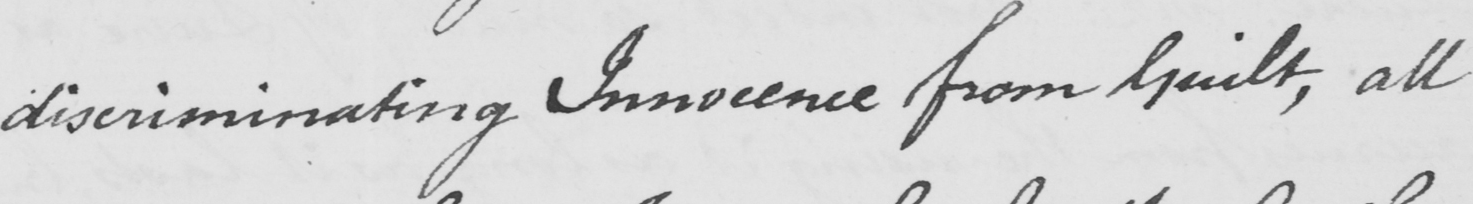Can you read and transcribe this handwriting? discriminating Innocence from Guilt , all 